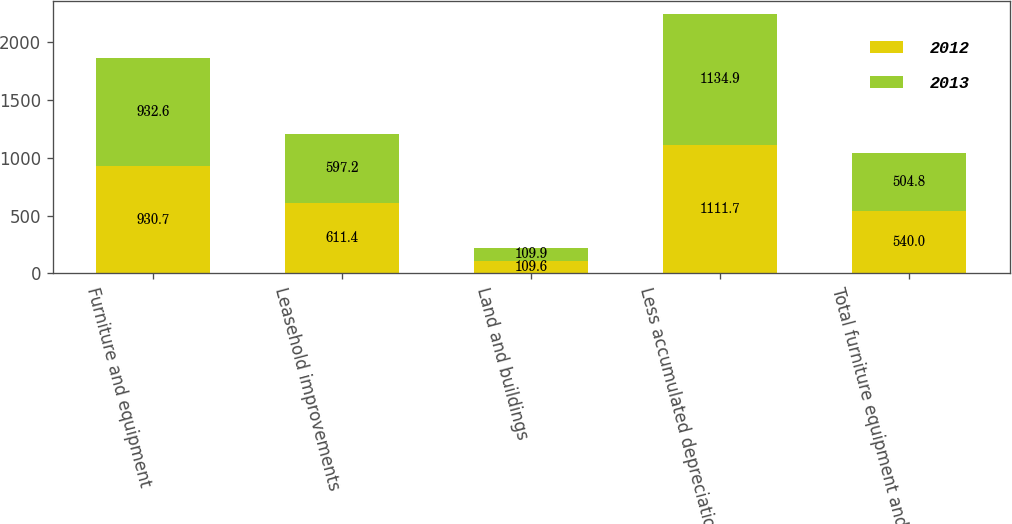Convert chart. <chart><loc_0><loc_0><loc_500><loc_500><stacked_bar_chart><ecel><fcel>Furniture and equipment<fcel>Leasehold improvements<fcel>Land and buildings<fcel>Less accumulated depreciation<fcel>Total furniture equipment and<nl><fcel>2012<fcel>930.7<fcel>611.4<fcel>109.6<fcel>1111.7<fcel>540<nl><fcel>2013<fcel>932.6<fcel>597.2<fcel>109.9<fcel>1134.9<fcel>504.8<nl></chart> 